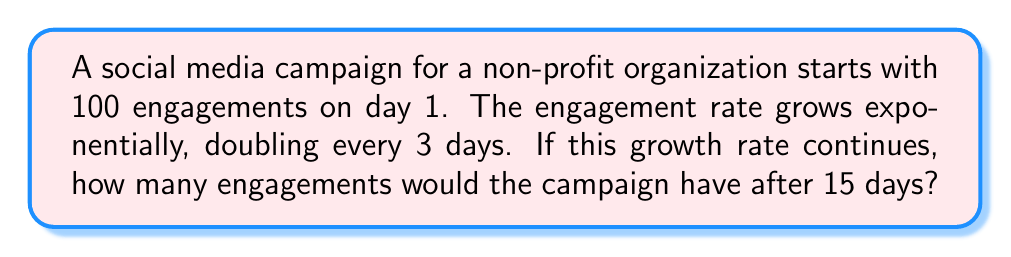Teach me how to tackle this problem. Let's approach this step-by-step:

1) First, we need to identify the key components of exponential growth:
   - Initial value: $a = 100$ engagements
   - Growth factor: doubles every 3 days, so $r = 2$
   - Time: $t = 15$ days

2) The general formula for exponential growth is:
   $$ A = a \cdot r^{t/p} $$
   Where $A$ is the final amount, $a$ is the initial amount, $r$ is the growth factor, $t$ is the time, and $p$ is the period over which growth occurs.

3) In this case, $p = 3$ because the doubling occurs every 3 days.

4) Plugging in our values:
   $$ A = 100 \cdot 2^{15/3} $$

5) Simplify the exponent:
   $$ A = 100 \cdot 2^5 $$

6) Calculate $2^5$:
   $$ A = 100 \cdot 32 $$

7) Multiply:
   $$ A = 3200 $$

Therefore, after 15 days, the campaign would have 3200 engagements.
Answer: 3200 engagements 